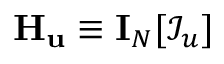Convert formula to latex. <formula><loc_0><loc_0><loc_500><loc_500>H _ { u } \equiv I _ { N } [ \mathcal { I } _ { u } ]</formula> 